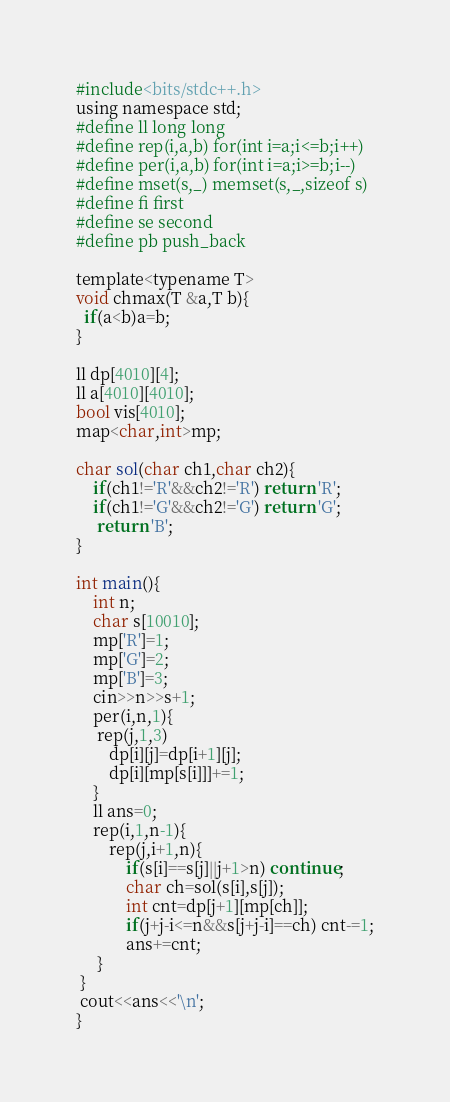Convert code to text. <code><loc_0><loc_0><loc_500><loc_500><_C_>#include<bits/stdc++.h>
using namespace std;
#define ll long long
#define rep(i,a,b) for(int i=a;i<=b;i++)
#define per(i,a,b) for(int i=a;i>=b;i--)
#define mset(s,_) memset(s,_,sizeof s)
#define fi first
#define se second
#define pb push_back

template<typename T>
void chmax(T &a,T b){
  if(a<b)a=b;
}

ll dp[4010][4];
ll a[4010][4010];
bool vis[4010];
map<char,int>mp;

char sol(char ch1,char ch2){
	if(ch1!='R'&&ch2!='R') return 'R';
	if(ch1!='G'&&ch2!='G') return 'G';
	 return 'B';
}

int main(){
	int n;
	char s[10010];
	mp['R']=1;
	mp['G']=2;
	mp['B']=3;
	cin>>n>>s+1;
	per(i,n,1){
	 rep(j,1,3)
		dp[i][j]=dp[i+1][j];
		dp[i][mp[s[i]]]+=1;
	}
	ll ans=0;
	rep(i,1,n-1){
		rep(j,i+1,n){
			if(s[i]==s[j]||j+1>n) continue;
			char ch=sol(s[i],s[j]);
			int cnt=dp[j+1][mp[ch]];
			if(j+j-i<=n&&s[j+j-i]==ch) cnt-=1;
			ans+=cnt;
	 }
 }
 cout<<ans<<'\n';
}

</code> 